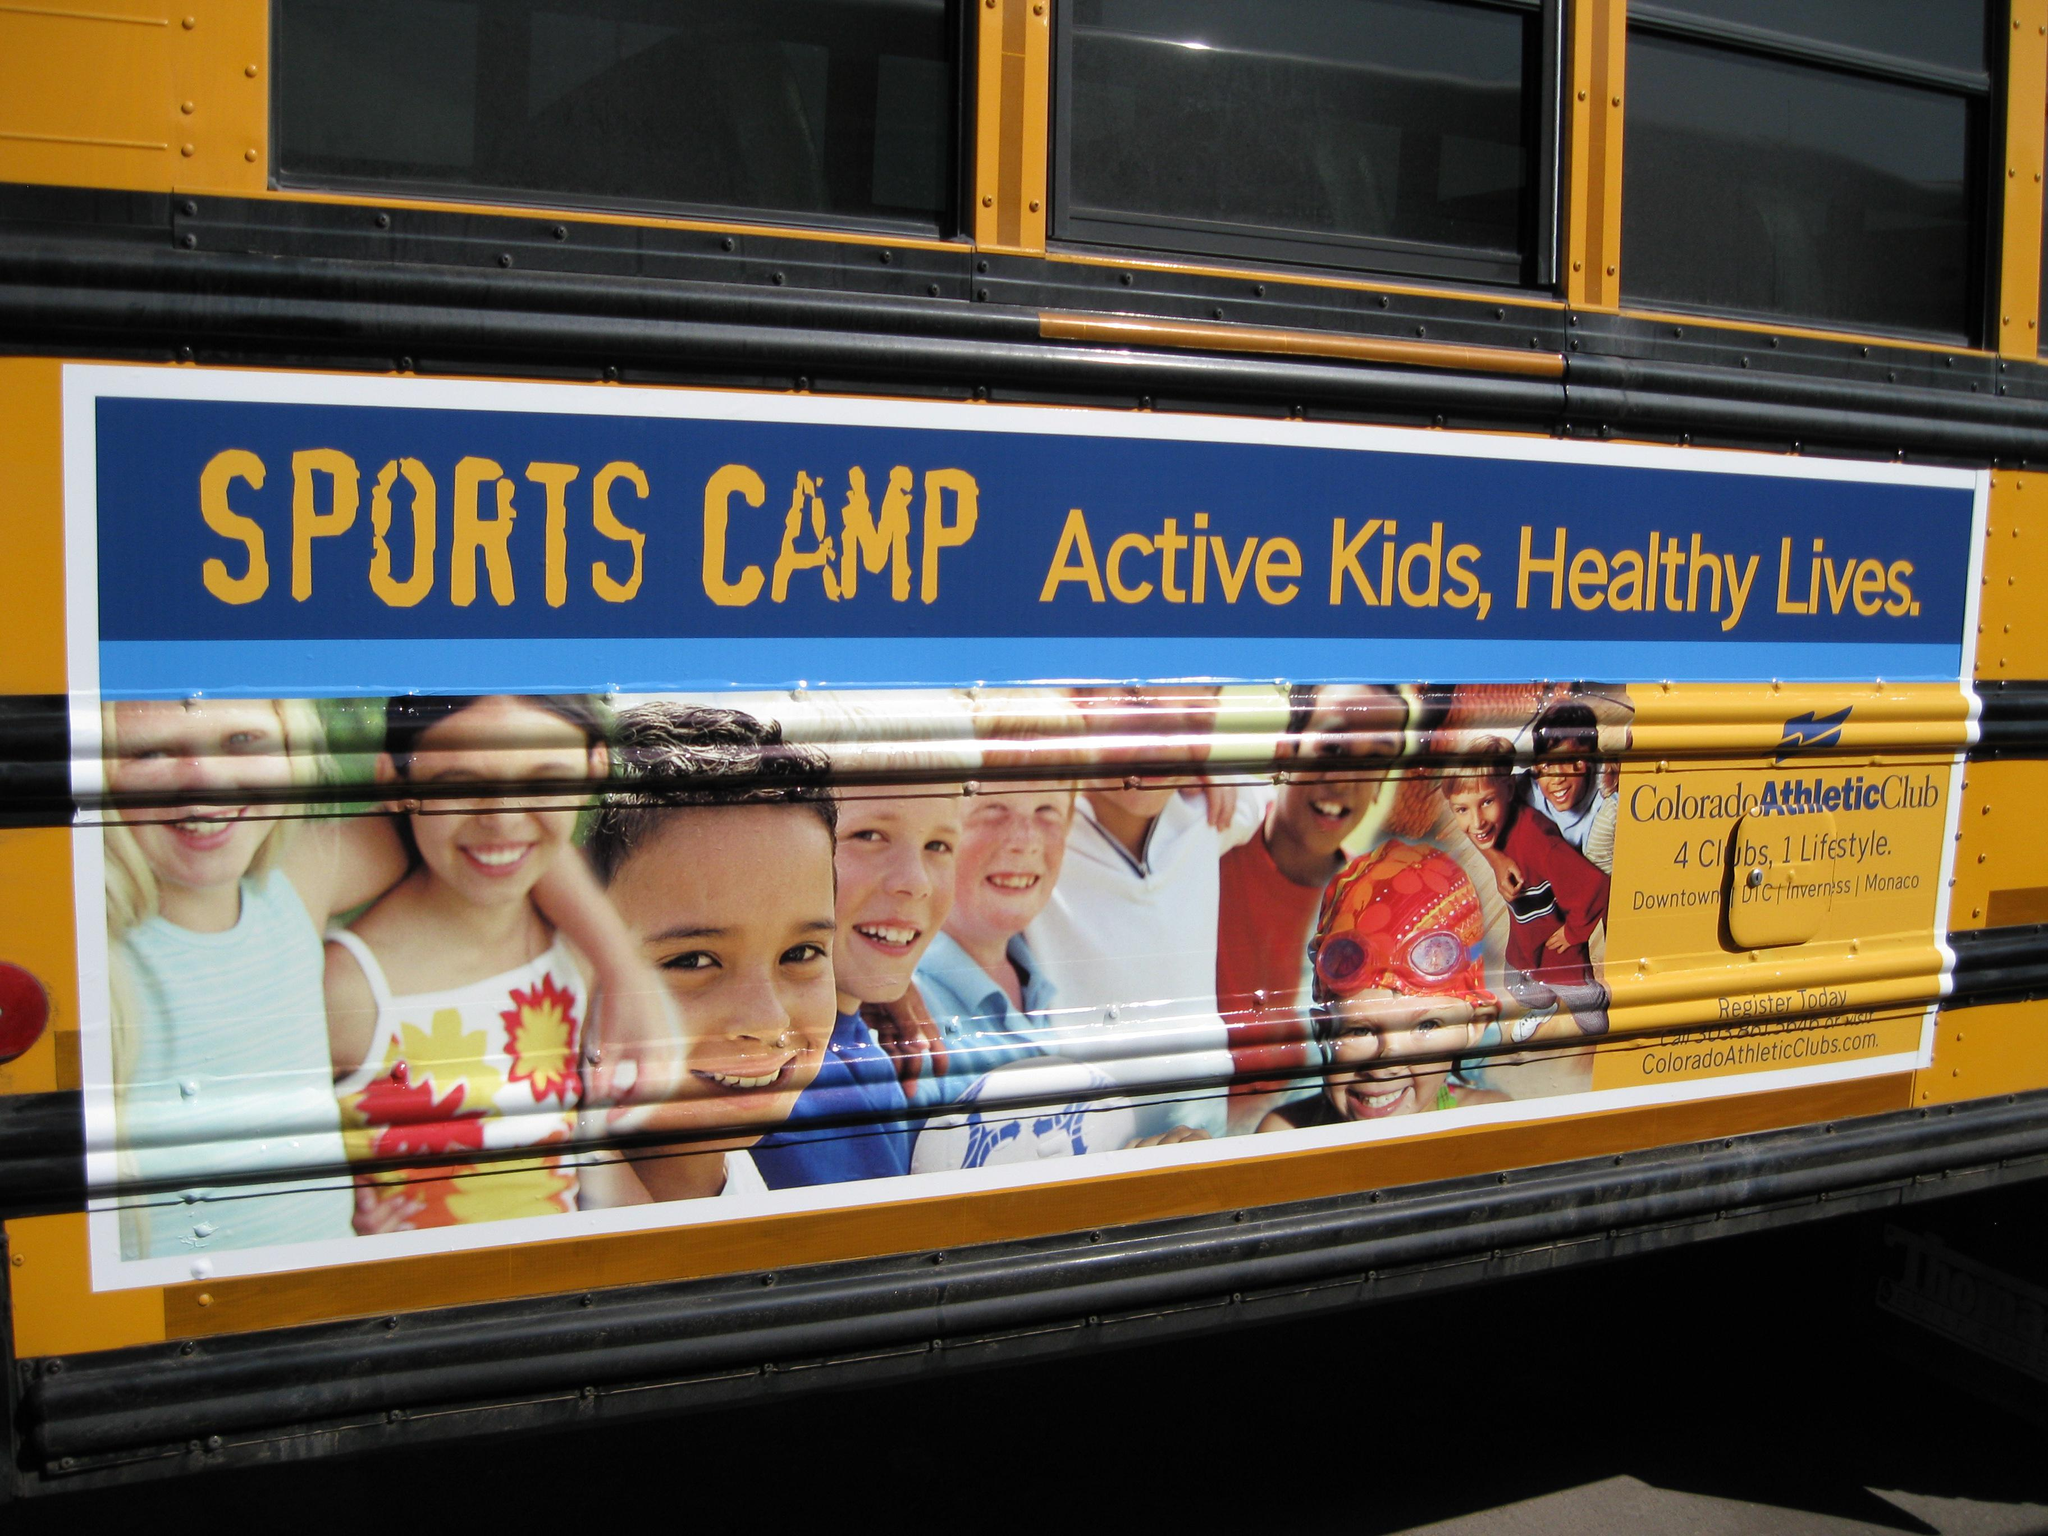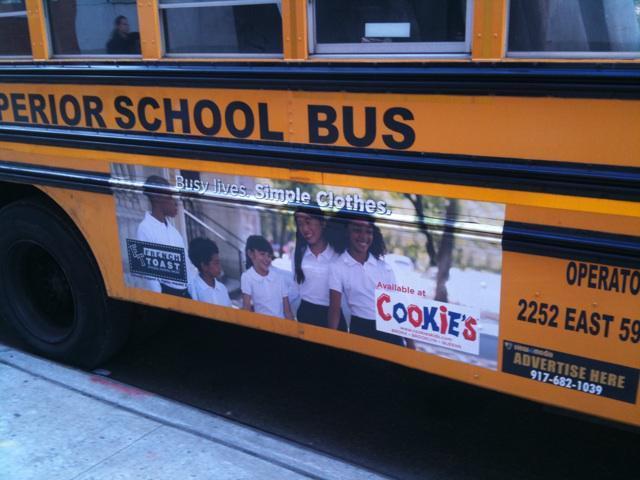The first image is the image on the left, the second image is the image on the right. Evaluate the accuracy of this statement regarding the images: "There is a bus with at least one shild in the advertizing on the side of the bus". Is it true? Answer yes or no. Yes. The first image is the image on the left, the second image is the image on the right. Analyze the images presented: Is the assertion "All images show a sign on the side of a school bus that contains at least one human face, and at least one image features a school bus sign with multiple kids faces on it." valid? Answer yes or no. Yes. 